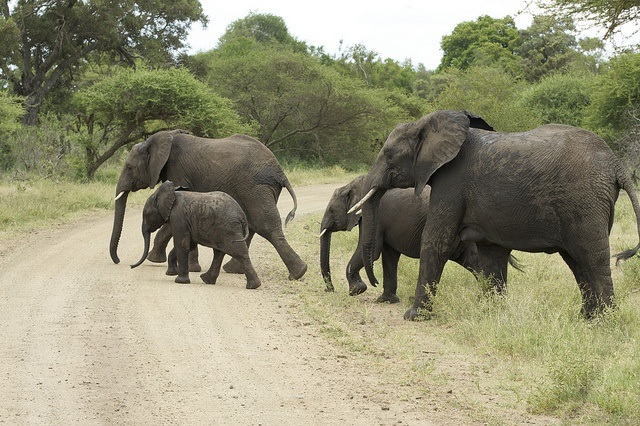Describe the objects in this image and their specific colors. I can see elephant in gray and black tones, elephant in gray and black tones, elephant in gray and black tones, and elephant in gray and black tones in this image. 